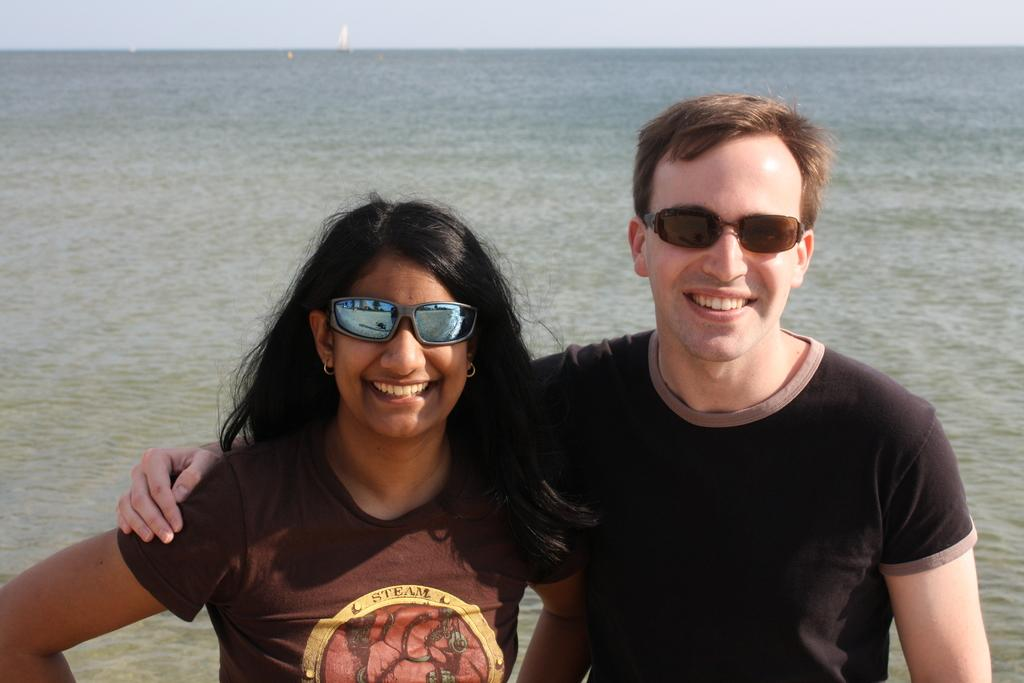How many people are in the image? There are two people in the image. What are the expressions on the faces of the people in the image? The two people are smiling. What are the people wearing in the image? The two people are wearing goggles. What can be seen in the background of the image? Water and the sky are visible in the background of the image. What type of education can be seen in the image? There is no reference to education in the image; it features two people wearing goggles and smiling. 